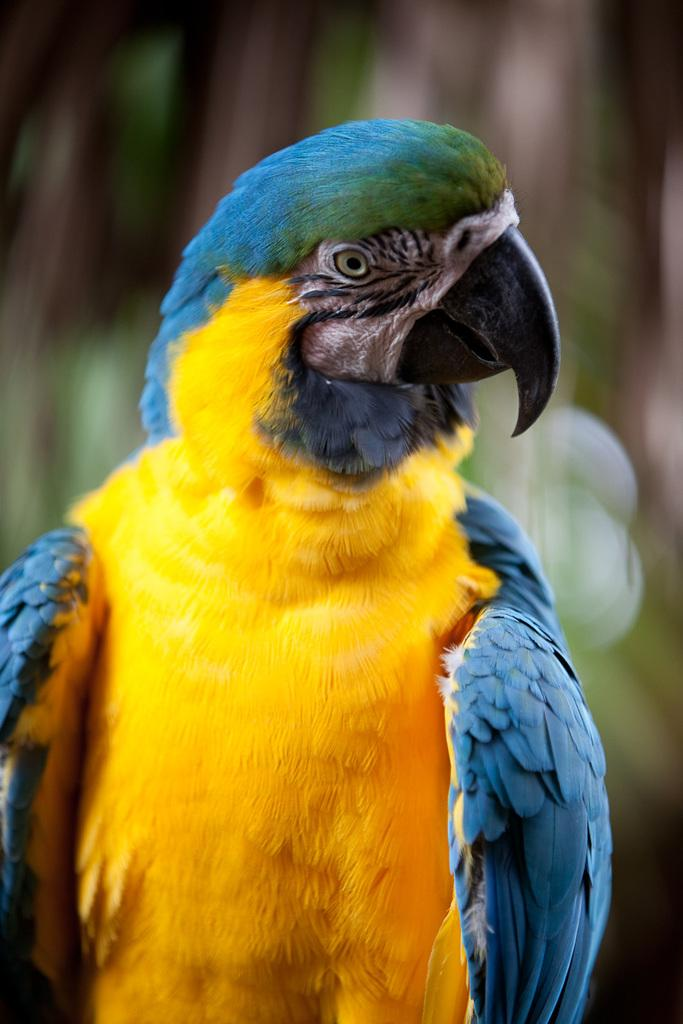What type of animal is in the image? There is a bird in the image. What colors can be seen on the bird? The bird has yellow and sky blue colors. Can you describe the background of the image? The background of the image is blurred. Are there any mountains visible in the image? There are no mountains present in the image; it features a bird with yellow and sky blue colors against a blurred background. 